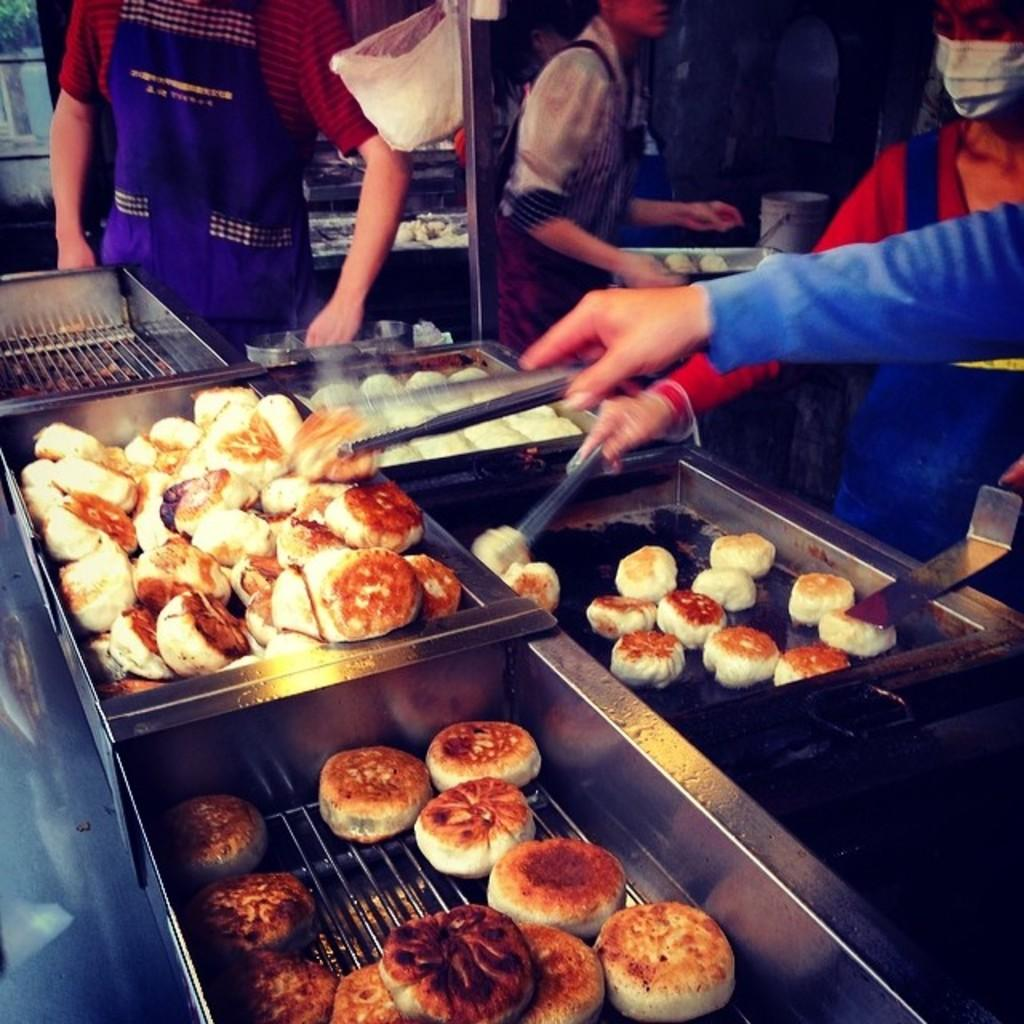What is the main subject in the center of the image? There is food in the center of the image. Where are the persons located in the image? The persons are standing on the right side of the image. Can you describe the hand in the center of the image? A hand holding food is visible in the center of the image. What type of glass is being used to hold the opinion in the image? There is no glass or opinion present in the image; it features food and persons. 